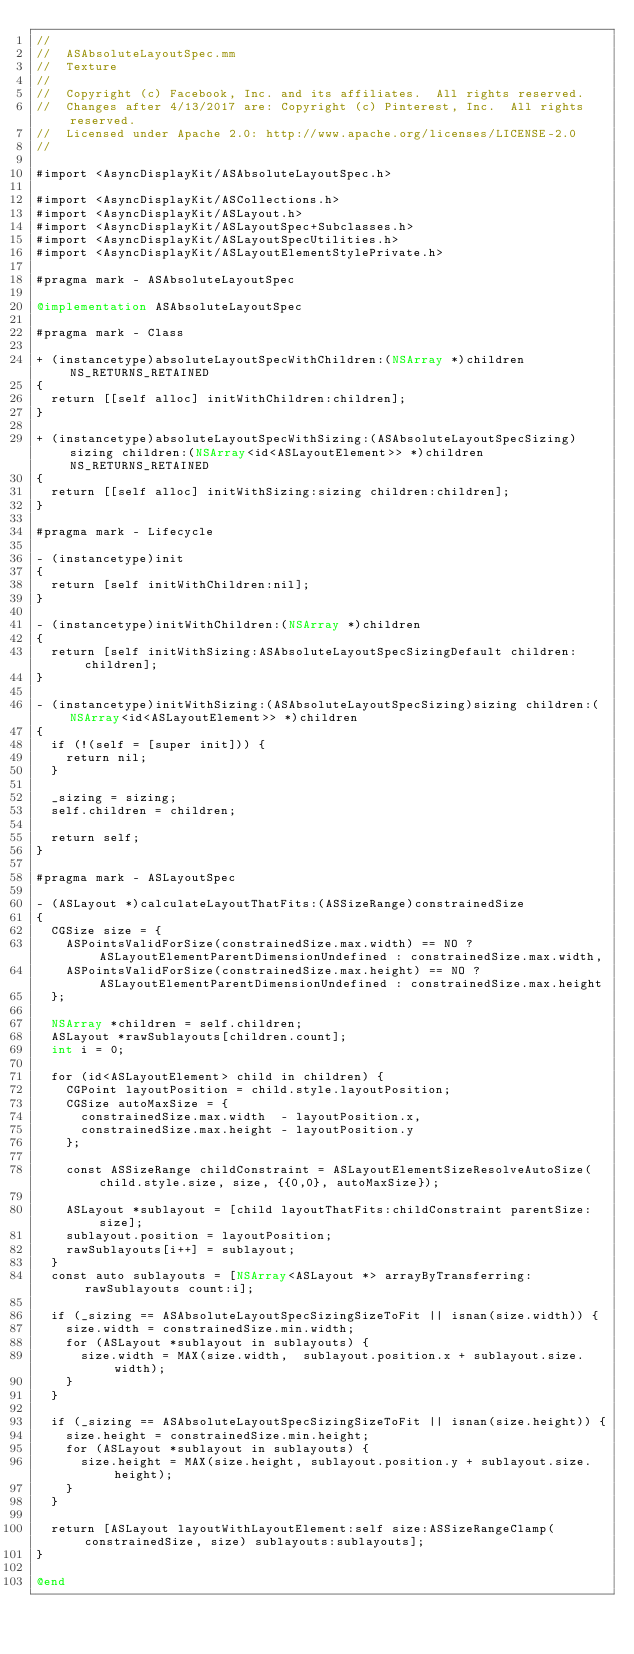Convert code to text. <code><loc_0><loc_0><loc_500><loc_500><_ObjectiveC_>//
//  ASAbsoluteLayoutSpec.mm
//  Texture
//
//  Copyright (c) Facebook, Inc. and its affiliates.  All rights reserved.
//  Changes after 4/13/2017 are: Copyright (c) Pinterest, Inc.  All rights reserved.
//  Licensed under Apache 2.0: http://www.apache.org/licenses/LICENSE-2.0
//

#import <AsyncDisplayKit/ASAbsoluteLayoutSpec.h>

#import <AsyncDisplayKit/ASCollections.h>
#import <AsyncDisplayKit/ASLayout.h>
#import <AsyncDisplayKit/ASLayoutSpec+Subclasses.h>
#import <AsyncDisplayKit/ASLayoutSpecUtilities.h>
#import <AsyncDisplayKit/ASLayoutElementStylePrivate.h>

#pragma mark - ASAbsoluteLayoutSpec

@implementation ASAbsoluteLayoutSpec

#pragma mark - Class

+ (instancetype)absoluteLayoutSpecWithChildren:(NSArray *)children NS_RETURNS_RETAINED
{
  return [[self alloc] initWithChildren:children];
}

+ (instancetype)absoluteLayoutSpecWithSizing:(ASAbsoluteLayoutSpecSizing)sizing children:(NSArray<id<ASLayoutElement>> *)children NS_RETURNS_RETAINED
{
  return [[self alloc] initWithSizing:sizing children:children];
}

#pragma mark - Lifecycle

- (instancetype)init
{
  return [self initWithChildren:nil];
}

- (instancetype)initWithChildren:(NSArray *)children
{
  return [self initWithSizing:ASAbsoluteLayoutSpecSizingDefault children:children];
}

- (instancetype)initWithSizing:(ASAbsoluteLayoutSpecSizing)sizing children:(NSArray<id<ASLayoutElement>> *)children
{
  if (!(self = [super init])) {
    return nil;
  }

  _sizing = sizing;
  self.children = children;

  return self;
}

#pragma mark - ASLayoutSpec

- (ASLayout *)calculateLayoutThatFits:(ASSizeRange)constrainedSize
{
  CGSize size = {
    ASPointsValidForSize(constrainedSize.max.width) == NO ? ASLayoutElementParentDimensionUndefined : constrainedSize.max.width,
    ASPointsValidForSize(constrainedSize.max.height) == NO ? ASLayoutElementParentDimensionUndefined : constrainedSize.max.height
  };
  
  NSArray *children = self.children;
  ASLayout *rawSublayouts[children.count];
  int i = 0;

  for (id<ASLayoutElement> child in children) {
    CGPoint layoutPosition = child.style.layoutPosition;
    CGSize autoMaxSize = {
      constrainedSize.max.width  - layoutPosition.x,
      constrainedSize.max.height - layoutPosition.y
    };

    const ASSizeRange childConstraint = ASLayoutElementSizeResolveAutoSize(child.style.size, size, {{0,0}, autoMaxSize});
    
    ASLayout *sublayout = [child layoutThatFits:childConstraint parentSize:size];
    sublayout.position = layoutPosition;
    rawSublayouts[i++] = sublayout;
  }
  const auto sublayouts = [NSArray<ASLayout *> arrayByTransferring:rawSublayouts count:i];

  if (_sizing == ASAbsoluteLayoutSpecSizingSizeToFit || isnan(size.width)) {
    size.width = constrainedSize.min.width;
    for (ASLayout *sublayout in sublayouts) {
      size.width = MAX(size.width,  sublayout.position.x + sublayout.size.width);
    }
  }
  
  if (_sizing == ASAbsoluteLayoutSpecSizingSizeToFit || isnan(size.height)) {
    size.height = constrainedSize.min.height;
    for (ASLayout *sublayout in sublayouts) {
      size.height = MAX(size.height, sublayout.position.y + sublayout.size.height);
    }
  }
  
  return [ASLayout layoutWithLayoutElement:self size:ASSizeRangeClamp(constrainedSize, size) sublayouts:sublayouts];
}

@end

</code> 